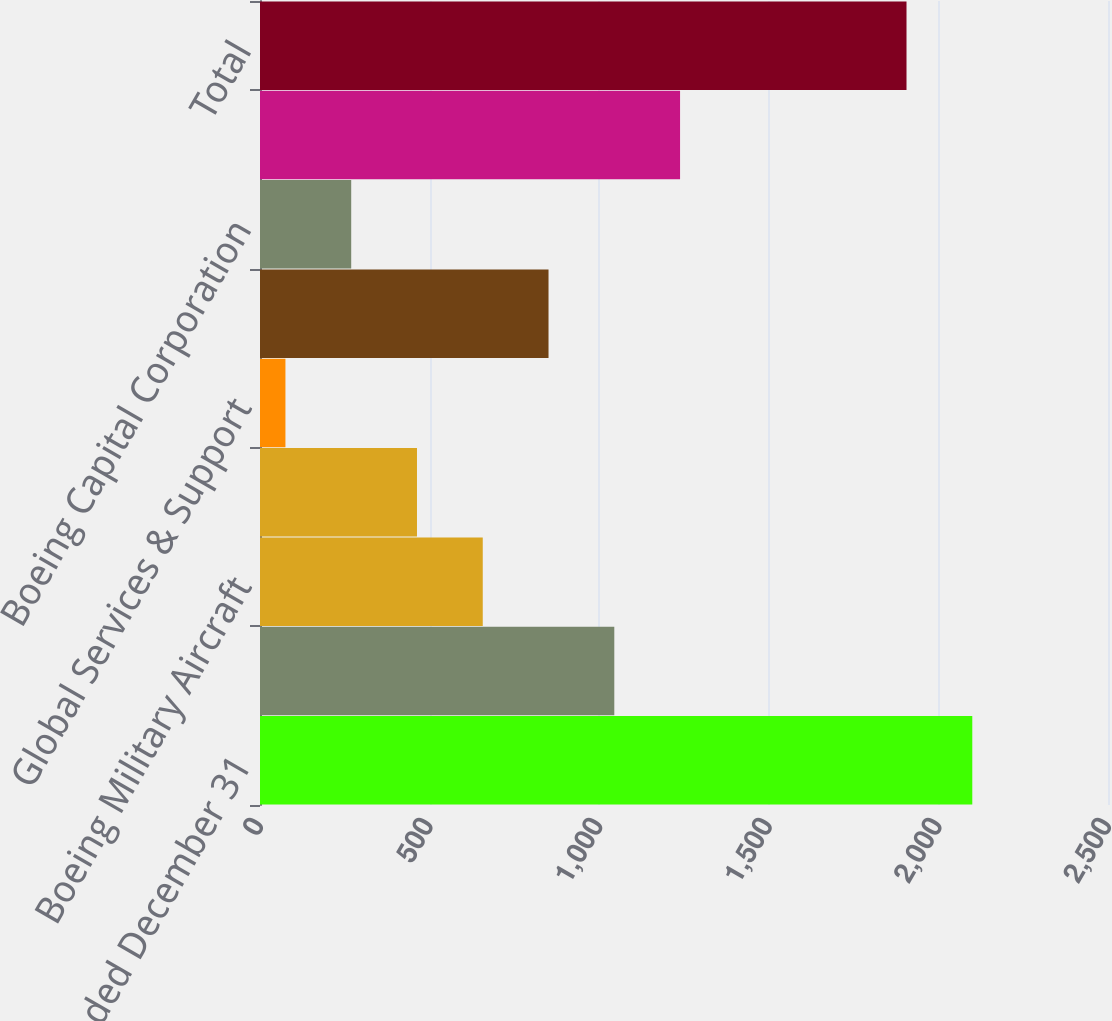Convert chart. <chart><loc_0><loc_0><loc_500><loc_500><bar_chart><fcel>Years ended December 31<fcel>Commercial Airplanes<fcel>Boeing Military Aircraft<fcel>Network & Space Systems<fcel>Global Services & Support<fcel>Total Defense Space & Security<fcel>Boeing Capital Corporation<fcel>Unallocated items eliminations<fcel>Total<nl><fcel>2099.9<fcel>1044.5<fcel>656.7<fcel>462.8<fcel>75<fcel>850.6<fcel>268.9<fcel>1238.4<fcel>1906<nl></chart> 